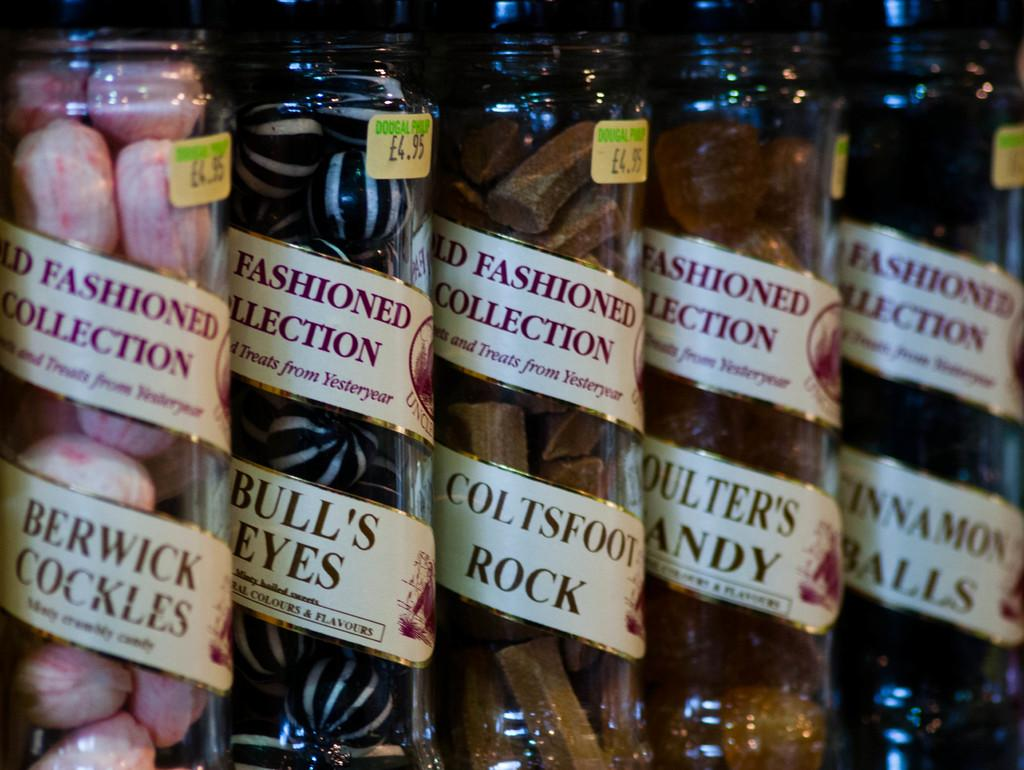What type of containers are visible in the image? There are glass containers in the image. What can be found inside the glass containers? The glass containers have objects in them. How can the contents of the containers be identified? There are labels with text on the containers. Is there any information about the cost of the items in the containers? Yes, there are price tags on the containers. What type of ball is being used in the argument in the image? There is no ball or argument present in the image; it only features glass containers with objects, labels, and price tags. 